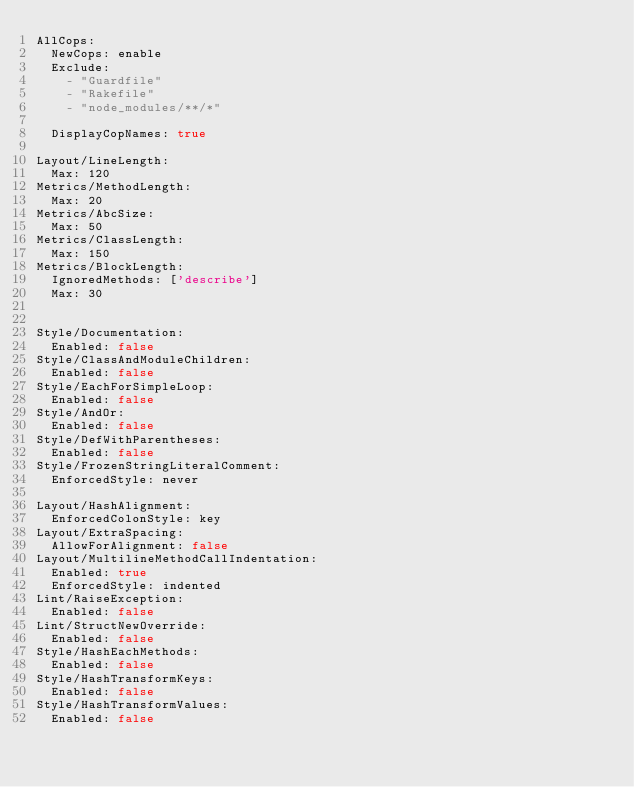<code> <loc_0><loc_0><loc_500><loc_500><_YAML_>AllCops:
  NewCops: enable
  Exclude:
    - "Guardfile"
    - "Rakefile"
    - "node_modules/**/*"

  DisplayCopNames: true

Layout/LineLength:
  Max: 120
Metrics/MethodLength:
  Max: 20
Metrics/AbcSize:
  Max: 50
Metrics/ClassLength:
  Max: 150
Metrics/BlockLength:
  IgnoredMethods: ['describe']
  Max: 30


Style/Documentation:
  Enabled: false
Style/ClassAndModuleChildren:
  Enabled: false
Style/EachForSimpleLoop:
  Enabled: false
Style/AndOr:
  Enabled: false
Style/DefWithParentheses:
  Enabled: false
Style/FrozenStringLiteralComment:
  EnforcedStyle: never

Layout/HashAlignment:
  EnforcedColonStyle: key
Layout/ExtraSpacing:
  AllowForAlignment: false
Layout/MultilineMethodCallIndentation:
  Enabled: true
  EnforcedStyle: indented
Lint/RaiseException:
  Enabled: false
Lint/StructNewOverride:
  Enabled: false
Style/HashEachMethods:
  Enabled: false
Style/HashTransformKeys:
  Enabled: false
Style/HashTransformValues:
  Enabled: false

</code> 